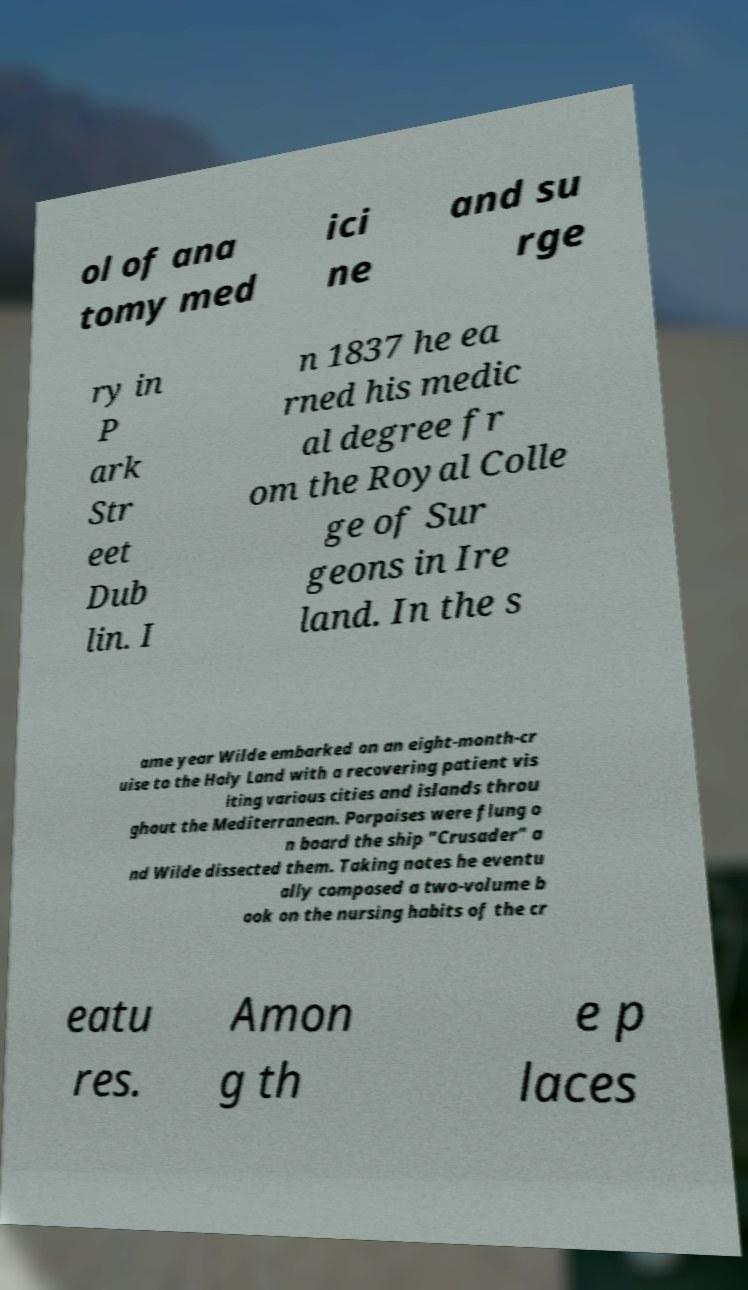Can you accurately transcribe the text from the provided image for me? ol of ana tomy med ici ne and su rge ry in P ark Str eet Dub lin. I n 1837 he ea rned his medic al degree fr om the Royal Colle ge of Sur geons in Ire land. In the s ame year Wilde embarked on an eight-month-cr uise to the Holy Land with a recovering patient vis iting various cities and islands throu ghout the Mediterranean. Porpoises were flung o n board the ship "Crusader" a nd Wilde dissected them. Taking notes he eventu ally composed a two-volume b ook on the nursing habits of the cr eatu res. Amon g th e p laces 